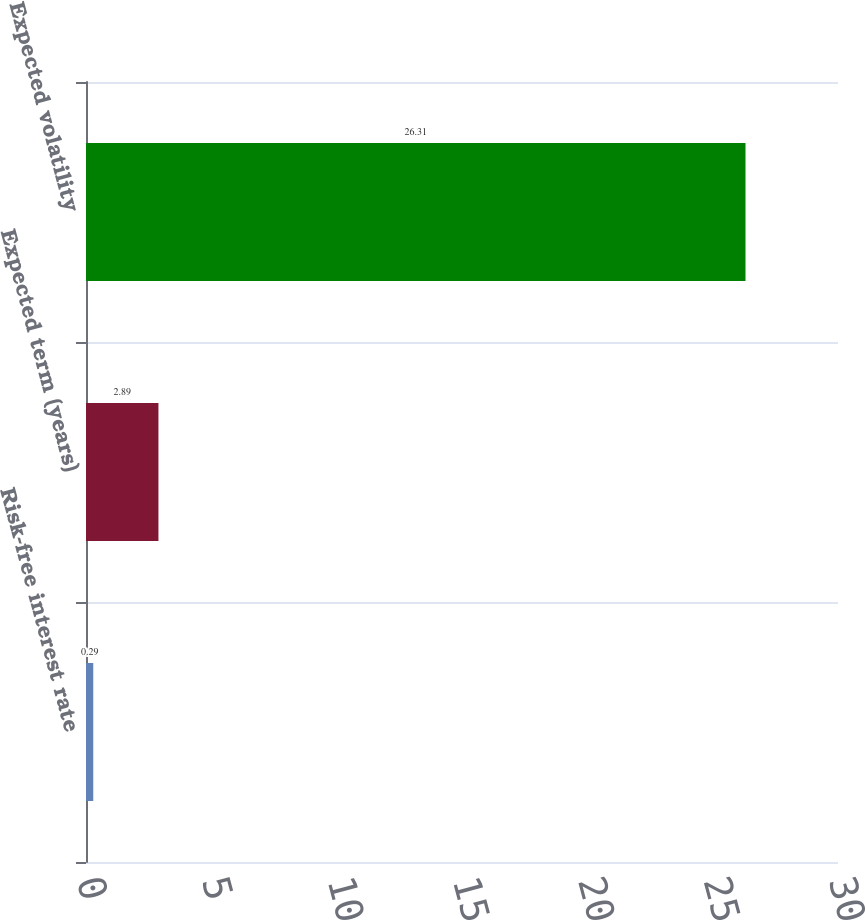Convert chart to OTSL. <chart><loc_0><loc_0><loc_500><loc_500><bar_chart><fcel>Risk-free interest rate<fcel>Expected term (years)<fcel>Expected volatility<nl><fcel>0.29<fcel>2.89<fcel>26.31<nl></chart> 